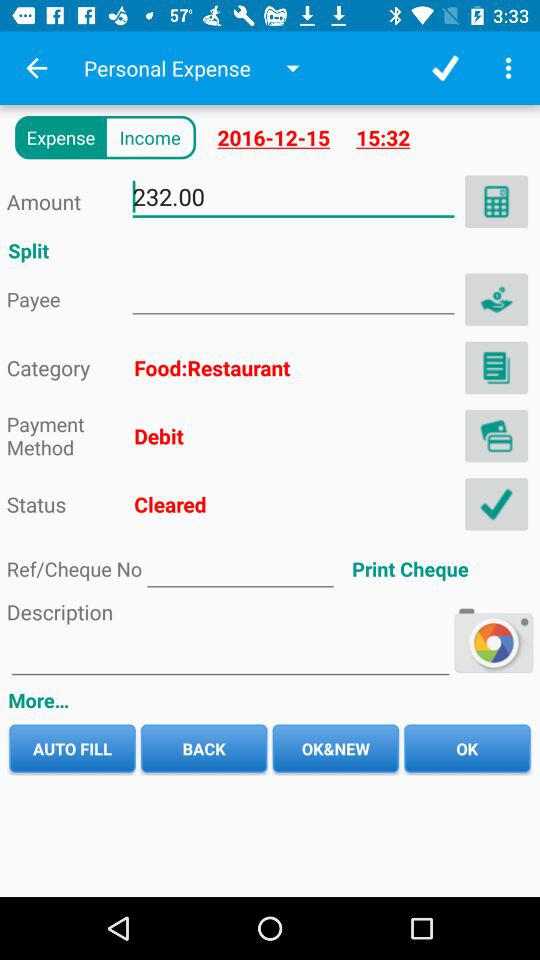What is the date of the expense? The date of the expense is December 15, 2016. 